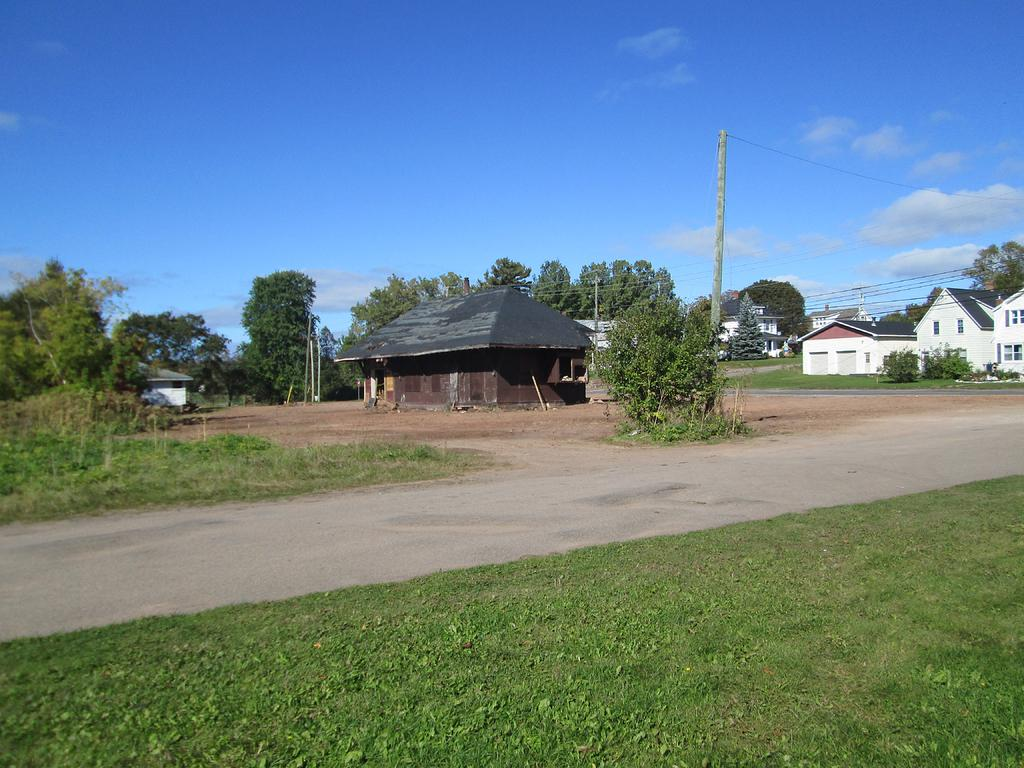What type of structures can be seen in the image? There are buildings in the image. What type of vegetation is present in the image? There are trees, plants, and grass in the image. What are the poles in the image used for? The poles in the image are likely used to support the cables. What can be seen in the background of the image? The sky is visible in the background of the image. Can you tell me how many stars are visible in the image? There are no stars visible in the image; only the sky is visible in the background. What type of comfort can be found in the image? The image does not depict any specific type of comfort; it shows buildings, trees, plants, poles, cables, grass, and the sky. 